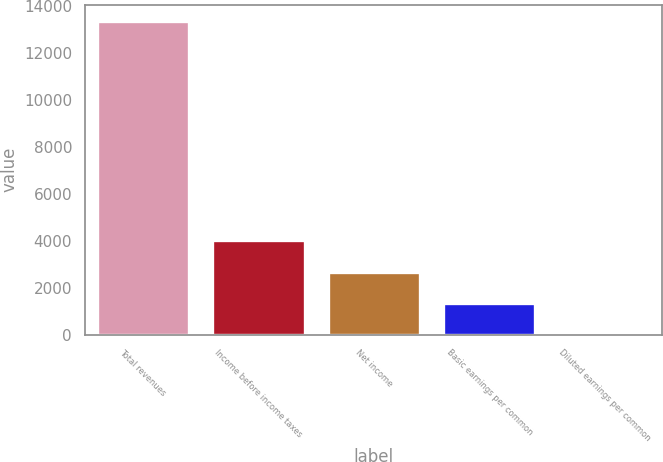Convert chart. <chart><loc_0><loc_0><loc_500><loc_500><bar_chart><fcel>Total revenues<fcel>Income before income taxes<fcel>Net income<fcel>Basic earnings per common<fcel>Diluted earnings per common<nl><fcel>13361<fcel>4008.76<fcel>2672.73<fcel>1336.7<fcel>0.67<nl></chart> 